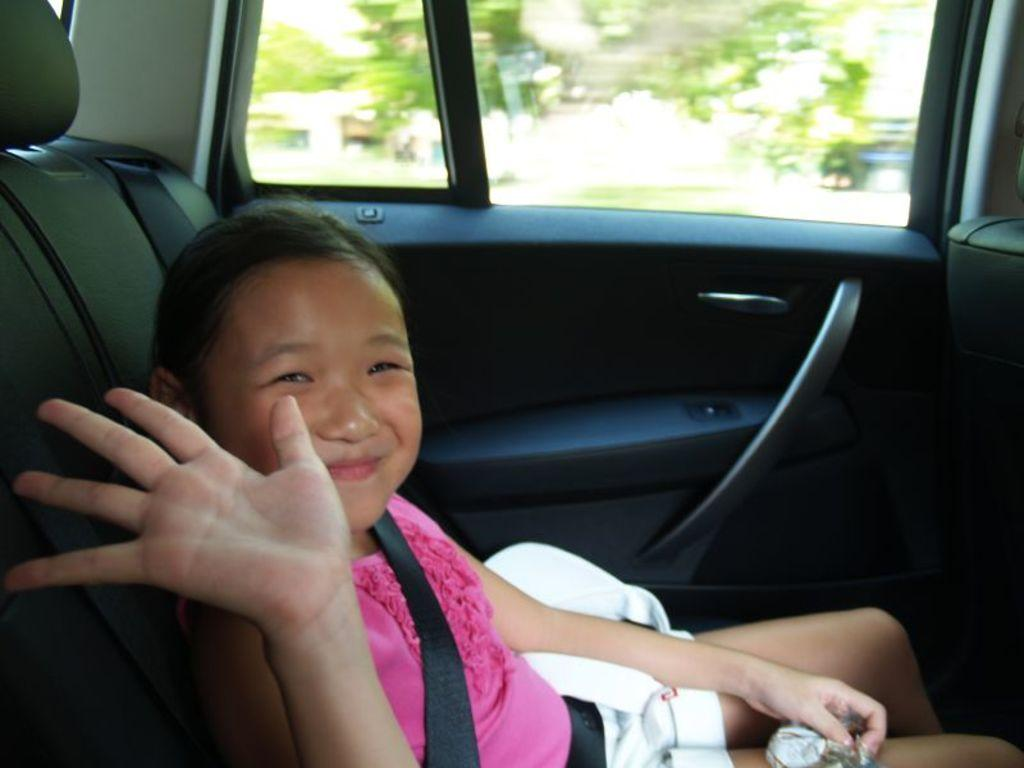What is the main subject in the middle of the image? There is a car in the middle of the image. Who is inside the car? There is a girl inside the car. What is the girl doing? The girl is smiling. What is the girl wearing? The girl is wearing a pink dress. What can be seen in the background of the image? There are trees in the background of the image. How many sponges are visible in the image? There are no sponges present in the image. What type of sticks are being used by the girl in the image? There is no indication of any sticks being used by the girl in the image. 